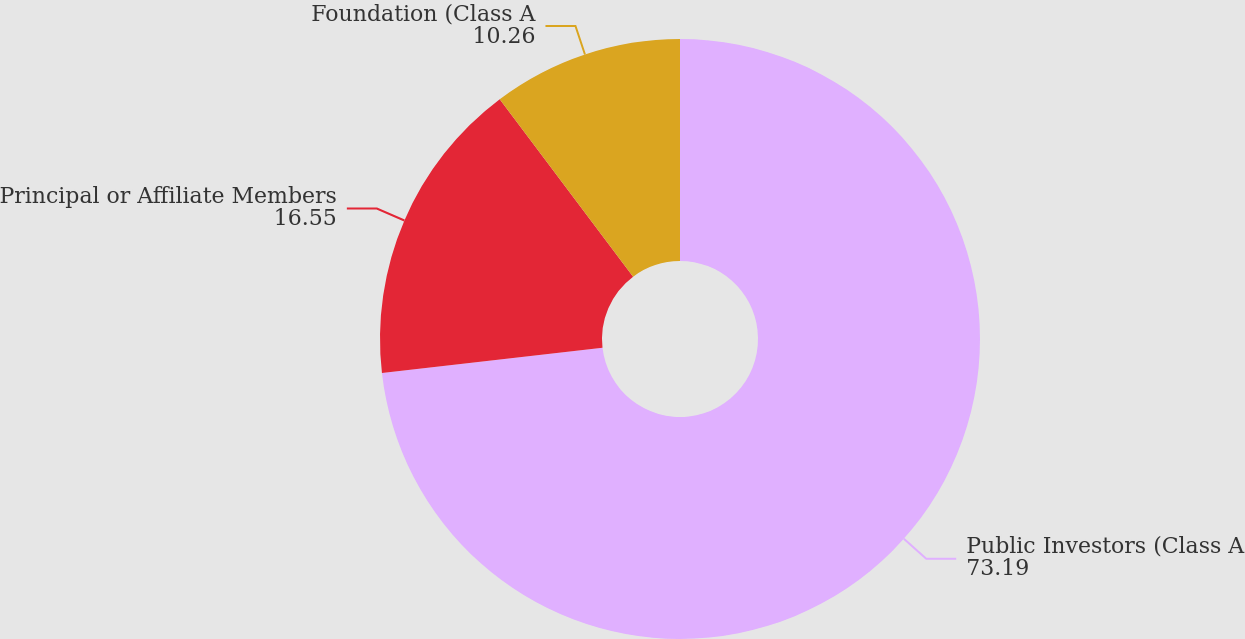Convert chart. <chart><loc_0><loc_0><loc_500><loc_500><pie_chart><fcel>Public Investors (Class A<fcel>Principal or Affiliate Members<fcel>Foundation (Class A<nl><fcel>73.19%<fcel>16.55%<fcel>10.26%<nl></chart> 